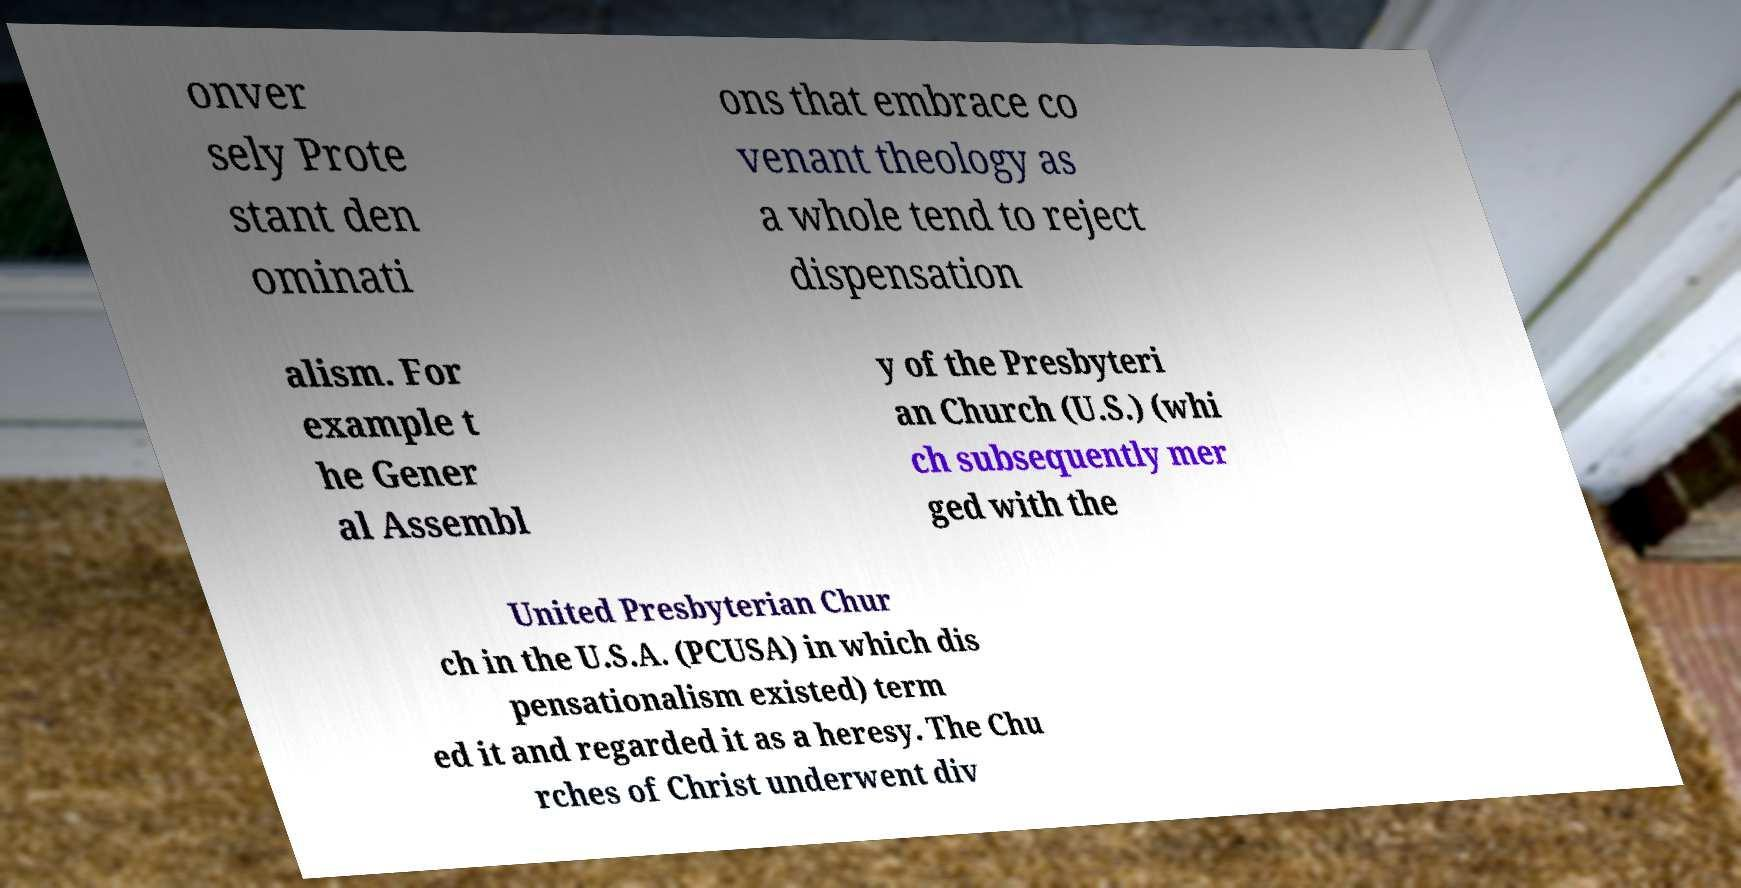Can you read and provide the text displayed in the image?This photo seems to have some interesting text. Can you extract and type it out for me? onver sely Prote stant den ominati ons that embrace co venant theology as a whole tend to reject dispensation alism. For example t he Gener al Assembl y of the Presbyteri an Church (U.S.) (whi ch subsequently mer ged with the United Presbyterian Chur ch in the U.S.A. (PCUSA) in which dis pensationalism existed) term ed it and regarded it as a heresy. The Chu rches of Christ underwent div 